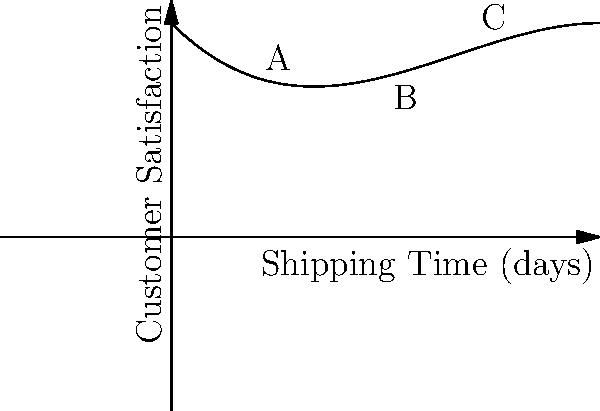The graph shows the relationship between shipping time and customer satisfaction for an online store. If the polynomial function for this curve is $f(x) = -0.01x^3 + 0.2x^2 - x + 5$, where $x$ represents shipping time in days and $f(x)$ represents customer satisfaction rating, at which point (A, B, or C) is the rate of change of customer satisfaction with respect to shipping time equal to zero? To find the point where the rate of change of customer satisfaction with respect to shipping time is zero, we need to follow these steps:

1) The rate of change is represented by the first derivative of the function. Let's find $f'(x)$:
   $f'(x) = -0.03x^2 + 0.4x - 1$

2) We want to find where $f'(x) = 0$:
   $-0.03x^2 + 0.4x - 1 = 0$

3) This is a quadratic equation. We can solve it using the quadratic formula:
   $x = \frac{-b \pm \sqrt{b^2 - 4ac}}{2a}$

   Where $a = -0.03$, $b = 0.4$, and $c = -1$

4) Plugging in these values:
   $x = \frac{-0.4 \pm \sqrt{0.4^2 - 4(-0.03)(-1)}}{2(-0.03)}$

5) Solving this:
   $x \approx 2$ or $x \approx 11.33$

6) Since our graph only goes up to 10 days, we're only interested in the solution $x \approx 2$

7) Looking at the graph, point A is at $x = 2$

Therefore, the rate of change of customer satisfaction with respect to shipping time is equal to zero at point A.
Answer: A 